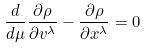<formula> <loc_0><loc_0><loc_500><loc_500>\frac { d } { d \mu } \frac { \partial \rho } { \partial v ^ { \lambda } } - \frac { \partial \rho } { \partial x ^ { \lambda } } = 0</formula> 